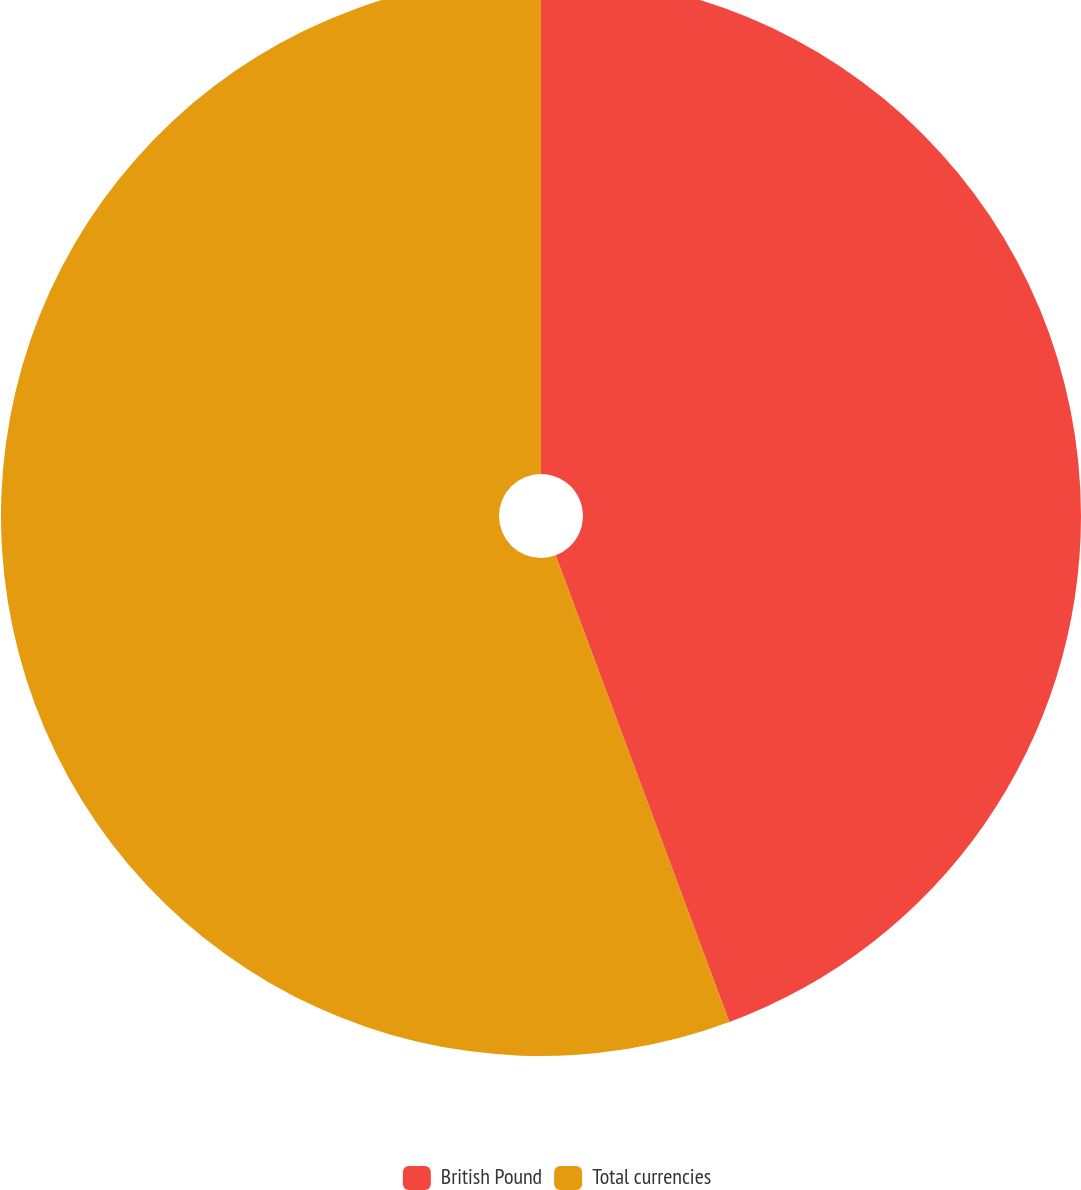Convert chart to OTSL. <chart><loc_0><loc_0><loc_500><loc_500><pie_chart><fcel>British Pound<fcel>Total currencies<nl><fcel>44.33%<fcel>55.67%<nl></chart> 